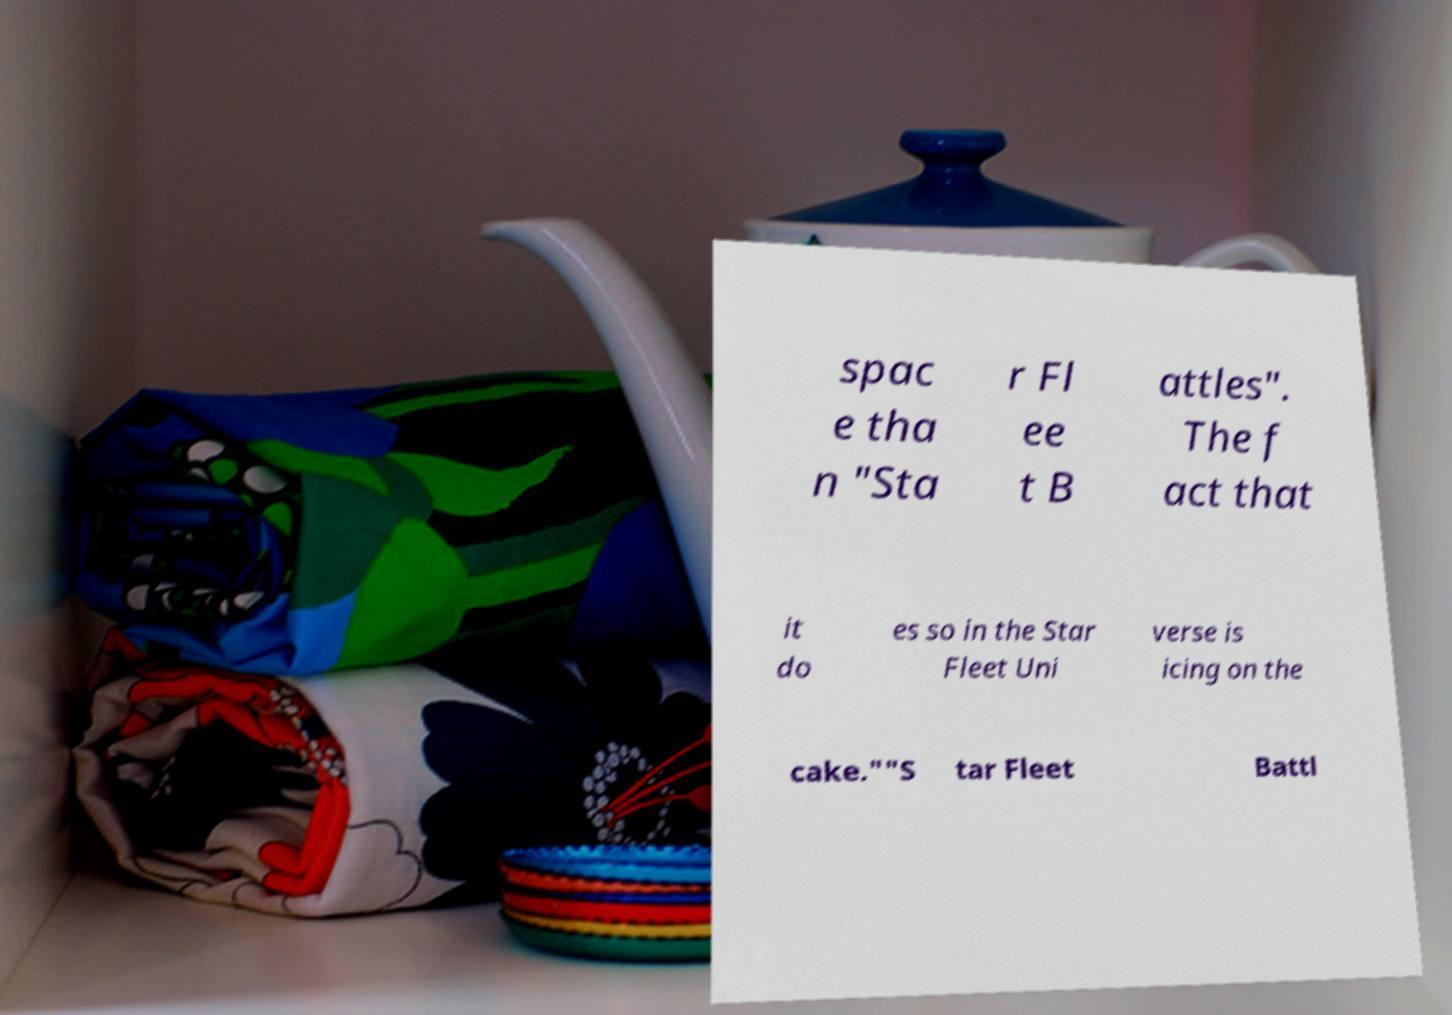There's text embedded in this image that I need extracted. Can you transcribe it verbatim? spac e tha n "Sta r Fl ee t B attles". The f act that it do es so in the Star Fleet Uni verse is icing on the cake.""S tar Fleet Battl 